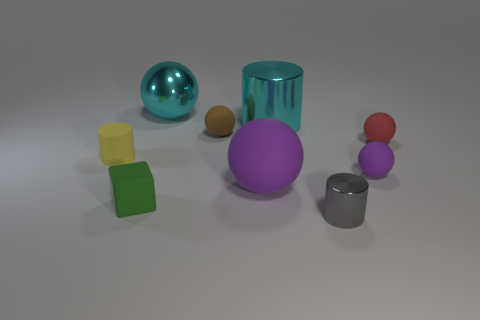There is a tiny cylinder that is on the left side of the big rubber object; is its color the same as the big ball that is in front of the big cyan metallic ball?
Offer a very short reply. No. What number of things are either purple spheres or large shiny balls?
Your answer should be compact. 3. What number of green blocks are made of the same material as the tiny gray cylinder?
Keep it short and to the point. 0. Are there fewer cyan cylinders than tiny matte objects?
Ensure brevity in your answer.  Yes. Is the material of the tiny cylinder that is to the right of the small yellow cylinder the same as the brown object?
Give a very brief answer. No. How many cylinders are either small gray rubber things or yellow rubber things?
Offer a terse response. 1. There is a tiny rubber object that is both on the left side of the gray cylinder and to the right of the small rubber block; what shape is it?
Your response must be concise. Sphere. There is a small cylinder that is to the left of the cylinder on the right side of the cylinder that is behind the yellow thing; what is its color?
Your answer should be very brief. Yellow. Are there fewer cyan balls right of the small red rubber object than green rubber things?
Keep it short and to the point. Yes. Is the shape of the tiny metal object in front of the tiny yellow matte cylinder the same as the tiny matte object that is behind the red matte thing?
Your response must be concise. No. 